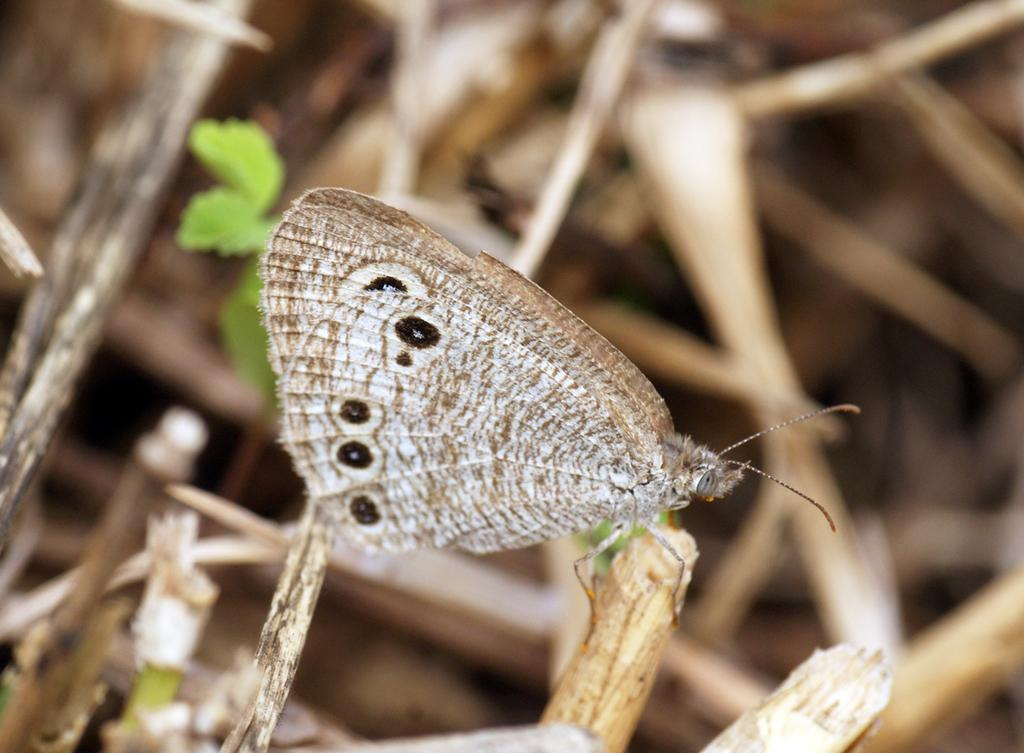What is the main subject of the image? There is a butterfly in the image. Can you describe the butterfly's appearance? The butterfly is brown in color. Where is the butterfly located in the image? The butterfly is sitting on a stem. What can be seen in the background of the image? There are plants and leaves present in the background of the image. How many ducks are swimming in the harbor in the image? There is no harbor or ducks present in the image; it features a brown butterfly sitting on a stem. What type of vessel is visible in the image? There is no vessel present in the image; it features a brown butterfly sitting on a stem. 